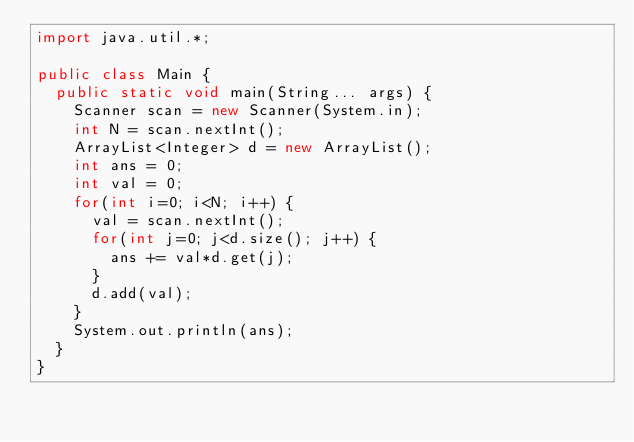Convert code to text. <code><loc_0><loc_0><loc_500><loc_500><_Java_>import java.util.*;

public class Main {
  public static void main(String... args) {
    Scanner scan = new Scanner(System.in);
    int N = scan.nextInt();
    ArrayList<Integer> d = new ArrayList();
    int ans = 0;
    int val = 0;
    for(int i=0; i<N; i++) {
      val = scan.nextInt();
      for(int j=0; j<d.size(); j++) {
        ans += val*d.get(j);
      }
      d.add(val);
    }
    System.out.println(ans);
  }
}</code> 